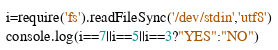Convert code to text. <code><loc_0><loc_0><loc_500><loc_500><_JavaScript_>i=require('fs').readFileSync('/dev/stdin','utf8')
console.log(i==7||i==5||i==3?"YES":"NO")</code> 